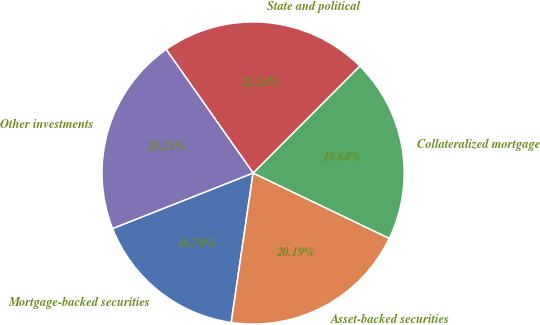Convert chart. <chart><loc_0><loc_0><loc_500><loc_500><pie_chart><fcel>Mortgage-backed securities<fcel>Asset-backed securities<fcel>Collateralized mortgage<fcel>State and political<fcel>Other investments<nl><fcel>16.7%<fcel>20.19%<fcel>19.64%<fcel>22.24%<fcel>21.23%<nl></chart> 